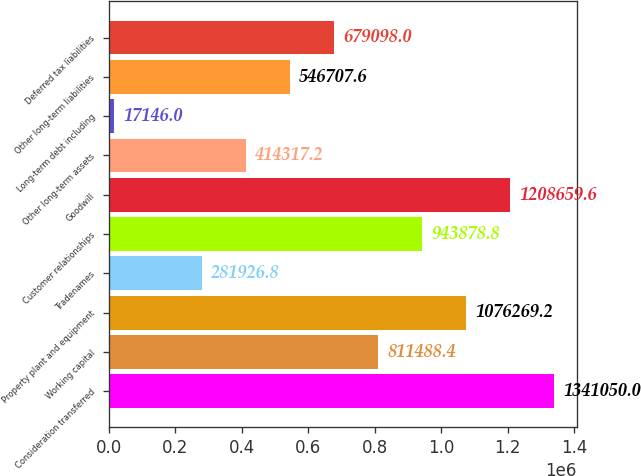<chart> <loc_0><loc_0><loc_500><loc_500><bar_chart><fcel>Consideration transferred<fcel>Working capital<fcel>Property plant and equipment<fcel>Tradenames<fcel>Customer relationships<fcel>Goodwill<fcel>Other long-term assets<fcel>Long-term debt including<fcel>Other long-term liabilities<fcel>Deferred tax liabilities<nl><fcel>1.34105e+06<fcel>811488<fcel>1.07627e+06<fcel>281927<fcel>943879<fcel>1.20866e+06<fcel>414317<fcel>17146<fcel>546708<fcel>679098<nl></chart> 